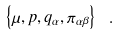Convert formula to latex. <formula><loc_0><loc_0><loc_500><loc_500>\left \{ \mu , p , q _ { \alpha } , \pi _ { \alpha \beta } \right \} \ .</formula> 